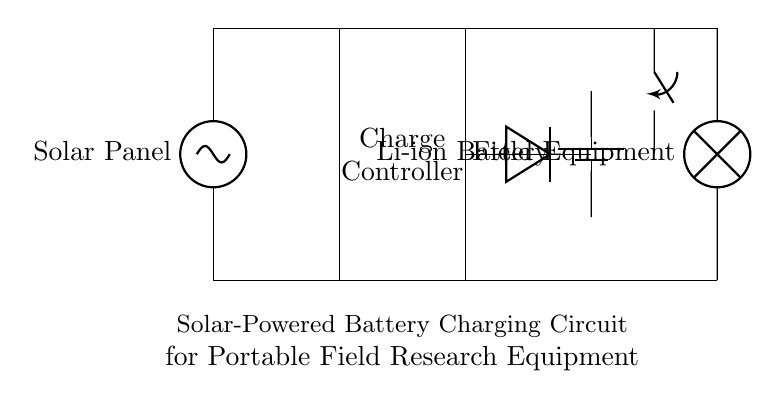What is the main function of the charge controller? The charge controller regulates the voltage and current from the solar panel to the battery, preventing overcharging and maintaining battery health.
Answer: Regulates charging What component provides reverse current protection? The diode in the circuit ensures that current does not flow back from the battery to the solar panel when there is no sunlight, protecting the solar panel from damage.
Answer: Diode Which component stores energy? The Li-ion battery is the energy storage component in the circuit, allowing for the use of stored energy to power the field equipment when needed.
Answer: Li-ion Battery What action does the switch perform in this circuit? The switch controls the connection between the battery and the field equipment, allowing you to turn the equipment on or off as needed.
Answer: Controls connection What is the relationship between the solar panel and the charge controller? The solar panel provides the voltage and current required to charge the battery, while the charge controller manages this process to ensure safe operation.
Answer: Charging relationship How does the circuit protect the battery? The charge controller prevents overcharging and the diode prevents reverse current, ensuring the battery is not damaged by excessive voltage or current flow.
Answer: Overcharging protection 